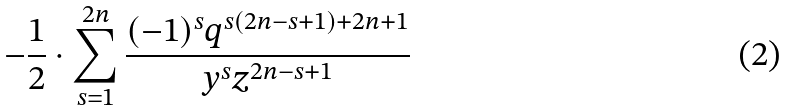<formula> <loc_0><loc_0><loc_500><loc_500>- \frac { 1 } { 2 } \cdot \sum _ { s = 1 } ^ { 2 n } \frac { ( - 1 ) ^ { s } q ^ { s ( 2 n - s + 1 ) + 2 n + 1 } } { y ^ { s } z ^ { 2 n - s + 1 } }</formula> 